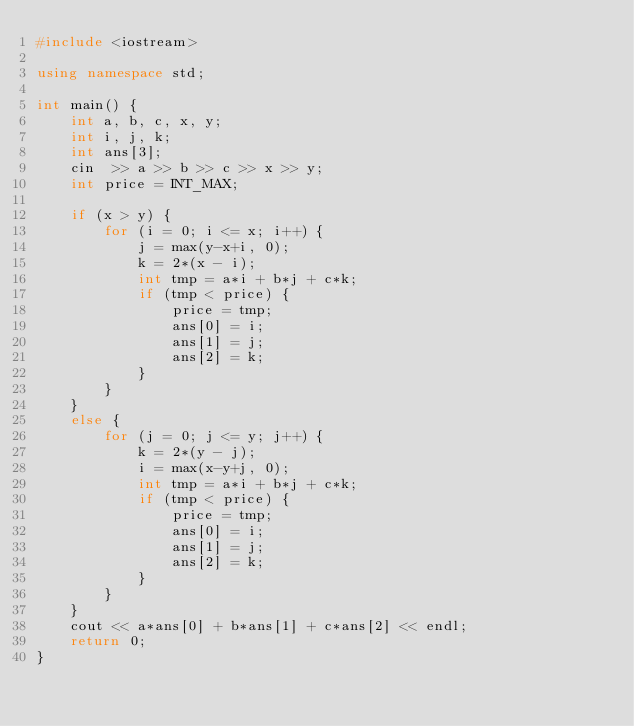<code> <loc_0><loc_0><loc_500><loc_500><_C++_>#include <iostream>

using namespace std;

int main() {
    int a, b, c, x, y;
    int i, j, k;
    int ans[3];
    cin  >> a >> b >> c >> x >> y;
    int price = INT_MAX;

    if (x > y) {
        for (i = 0; i <= x; i++) {
            j = max(y-x+i, 0);
            k = 2*(x - i);
            int tmp = a*i + b*j + c*k;
            if (tmp < price) {
                price = tmp;
                ans[0] = i;
                ans[1] = j; 
                ans[2] = k;
            }
        }
    }
    else {
        for (j = 0; j <= y; j++) {
            k = 2*(y - j);
            i = max(x-y+j, 0);
            int tmp = a*i + b*j + c*k;
            if (tmp < price) {
                price = tmp;
                ans[0] = i;
                ans[1] = j; 
                ans[2] = k;
            }
        }
    }
    cout << a*ans[0] + b*ans[1] + c*ans[2] << endl;
    return 0;
}</code> 